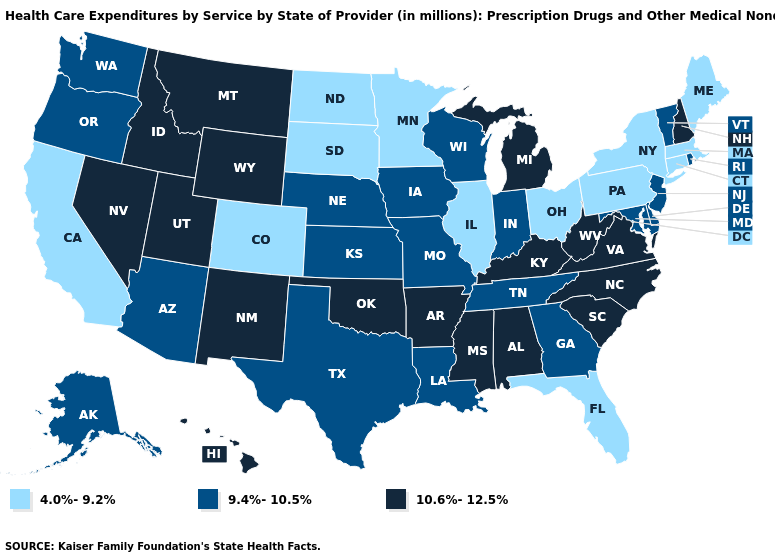Among the states that border Washington , which have the highest value?
Quick response, please. Idaho. What is the highest value in the MidWest ?
Quick response, please. 10.6%-12.5%. What is the lowest value in the MidWest?
Concise answer only. 4.0%-9.2%. What is the highest value in states that border Louisiana?
Give a very brief answer. 10.6%-12.5%. What is the lowest value in states that border Oklahoma?
Write a very short answer. 4.0%-9.2%. What is the value of Nevada?
Concise answer only. 10.6%-12.5%. Does Texas have the same value as Kansas?
Quick response, please. Yes. Which states have the highest value in the USA?
Answer briefly. Alabama, Arkansas, Hawaii, Idaho, Kentucky, Michigan, Mississippi, Montana, Nevada, New Hampshire, New Mexico, North Carolina, Oklahoma, South Carolina, Utah, Virginia, West Virginia, Wyoming. Does Minnesota have the same value as Idaho?
Write a very short answer. No. Name the states that have a value in the range 9.4%-10.5%?
Answer briefly. Alaska, Arizona, Delaware, Georgia, Indiana, Iowa, Kansas, Louisiana, Maryland, Missouri, Nebraska, New Jersey, Oregon, Rhode Island, Tennessee, Texas, Vermont, Washington, Wisconsin. What is the highest value in states that border North Carolina?
Keep it brief. 10.6%-12.5%. Does Louisiana have the highest value in the USA?
Give a very brief answer. No. What is the lowest value in the USA?
Answer briefly. 4.0%-9.2%. What is the highest value in the USA?
Quick response, please. 10.6%-12.5%. 